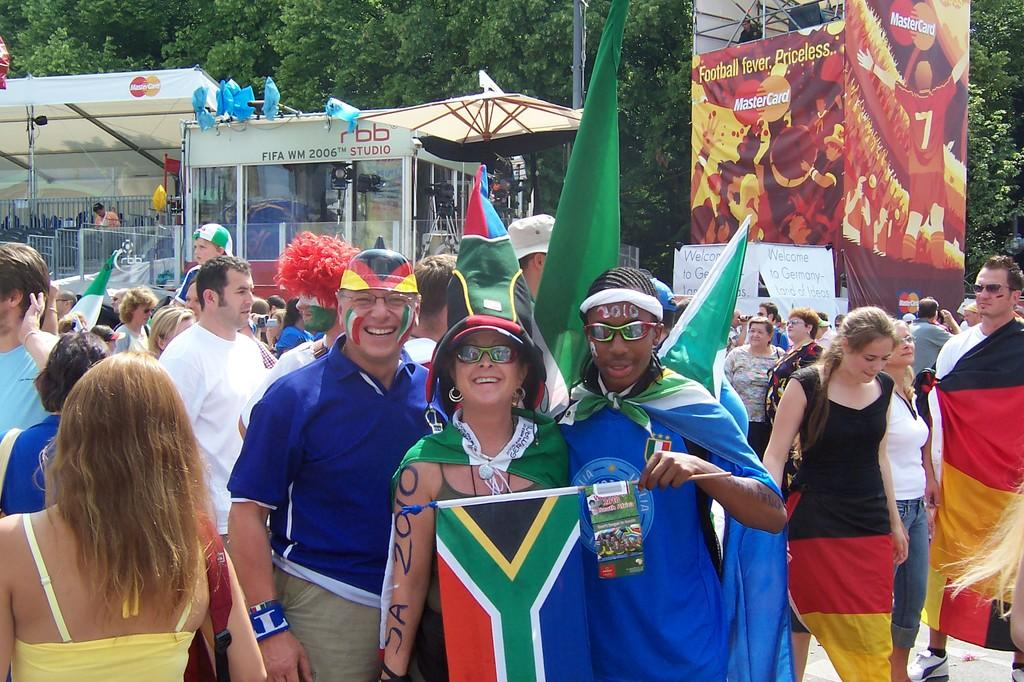How many people are standing in the image? There are three persons standing in the image. What can be seen in the background of the image? In the background, there is a group of people standing, holding flags, stalls, trees, and banners. What are the people in the background holding? The people in the background are holding flags. What type of rice is being cooked in the oven in the image? There is no oven or rice present in the image. 